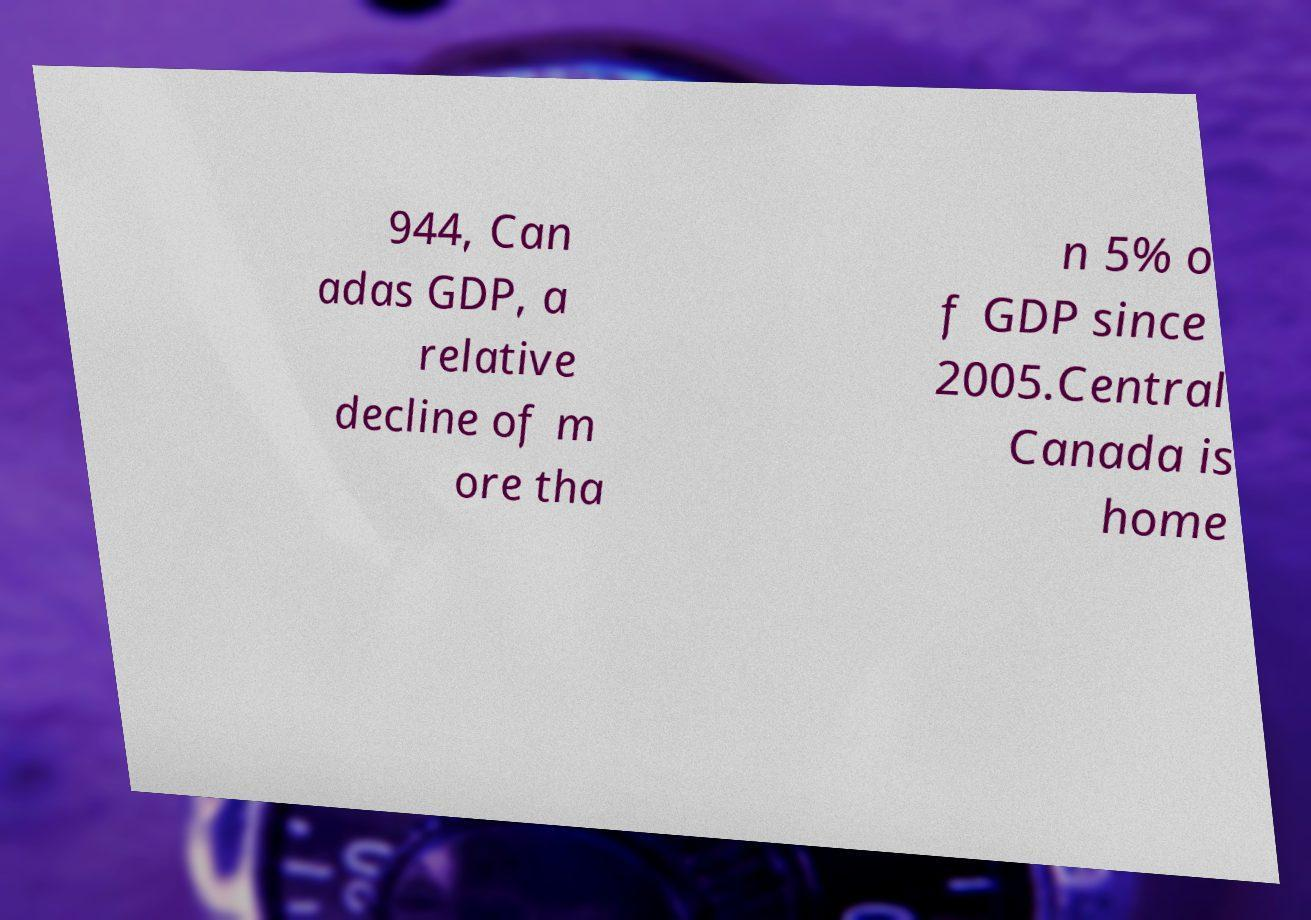Please read and relay the text visible in this image. What does it say? 944, Can adas GDP, a relative decline of m ore tha n 5% o f GDP since 2005.Central Canada is home 